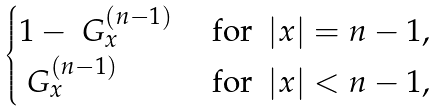<formula> <loc_0><loc_0><loc_500><loc_500>\begin{cases} 1 - \ G ^ { ( n - 1 ) } _ { x } & \ \text {for $\ |x|=n-1$} , \\ \ G ^ { ( n - 1 ) } _ { x } & \ \text {for $\ |x|<n-1$} , \\ \end{cases}</formula> 